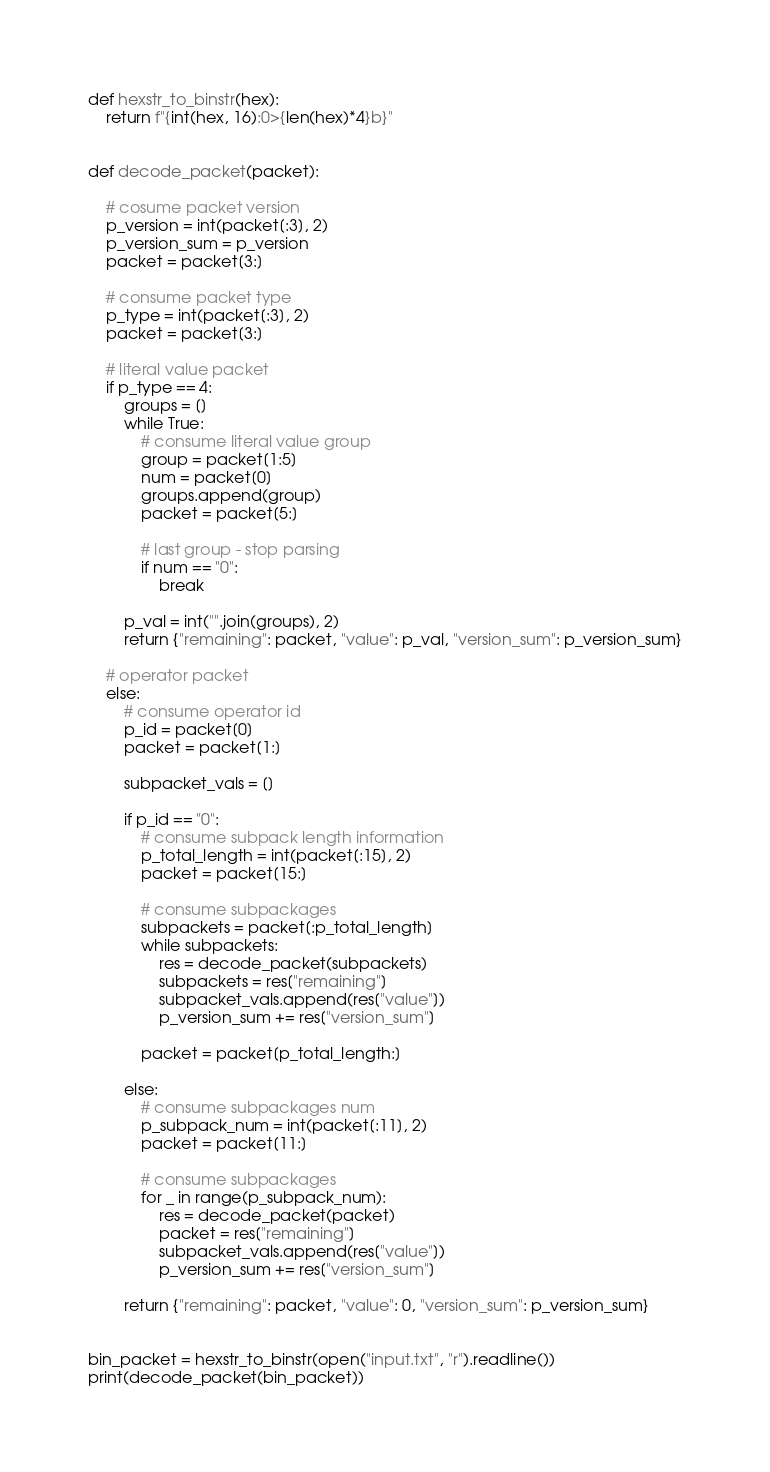Convert code to text. <code><loc_0><loc_0><loc_500><loc_500><_Python_>def hexstr_to_binstr(hex):
    return f"{int(hex, 16):0>{len(hex)*4}b}"


def decode_packet(packet):

    # cosume packet version
    p_version = int(packet[:3], 2)
    p_version_sum = p_version
    packet = packet[3:]

    # consume packet type
    p_type = int(packet[:3], 2)
    packet = packet[3:]

    # literal value packet
    if p_type == 4:
        groups = []
        while True:
            # consume literal value group
            group = packet[1:5]
            num = packet[0]
            groups.append(group)
            packet = packet[5:]

            # last group - stop parsing
            if num == "0":
                break

        p_val = int("".join(groups), 2)
        return {"remaining": packet, "value": p_val, "version_sum": p_version_sum}

    # operator packet
    else:
        # consume operator id
        p_id = packet[0]
        packet = packet[1:]

        subpacket_vals = []

        if p_id == "0":
            # consume subpack length information
            p_total_length = int(packet[:15], 2)
            packet = packet[15:]

            # consume subpackages
            subpackets = packet[:p_total_length]
            while subpackets:
                res = decode_packet(subpackets)
                subpackets = res["remaining"]
                subpacket_vals.append(res["value"])
                p_version_sum += res["version_sum"]

            packet = packet[p_total_length:]

        else:
            # consume subpackages num
            p_subpack_num = int(packet[:11], 2)
            packet = packet[11:]

            # consume subpackages
            for _ in range(p_subpack_num):
                res = decode_packet(packet)
                packet = res["remaining"]
                subpacket_vals.append(res["value"])
                p_version_sum += res["version_sum"]

        return {"remaining": packet, "value": 0, "version_sum": p_version_sum}


bin_packet = hexstr_to_binstr(open("input.txt", "r").readline())
print(decode_packet(bin_packet))

</code> 